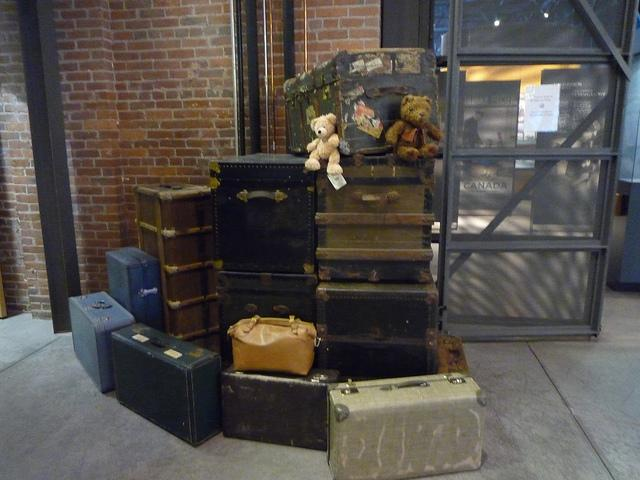What business is this display promoting? Please explain your reasoning. travel agency. A variety of suitcases are on display. suitcases are associated with travel. 